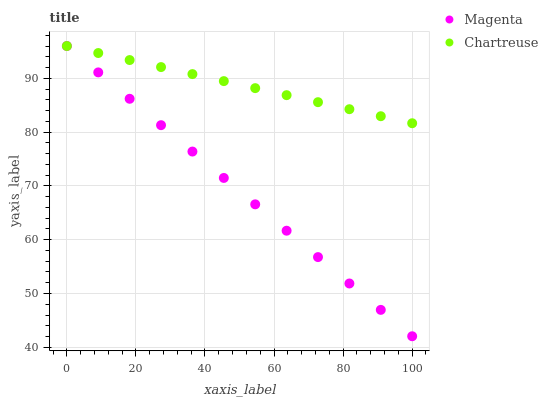Does Magenta have the minimum area under the curve?
Answer yes or no. Yes. Does Chartreuse have the maximum area under the curve?
Answer yes or no. Yes. Does Chartreuse have the minimum area under the curve?
Answer yes or no. No. Is Chartreuse the smoothest?
Answer yes or no. Yes. Is Magenta the roughest?
Answer yes or no. Yes. Is Chartreuse the roughest?
Answer yes or no. No. Does Magenta have the lowest value?
Answer yes or no. Yes. Does Chartreuse have the lowest value?
Answer yes or no. No. Does Chartreuse have the highest value?
Answer yes or no. Yes. Does Chartreuse intersect Magenta?
Answer yes or no. Yes. Is Chartreuse less than Magenta?
Answer yes or no. No. Is Chartreuse greater than Magenta?
Answer yes or no. No. 